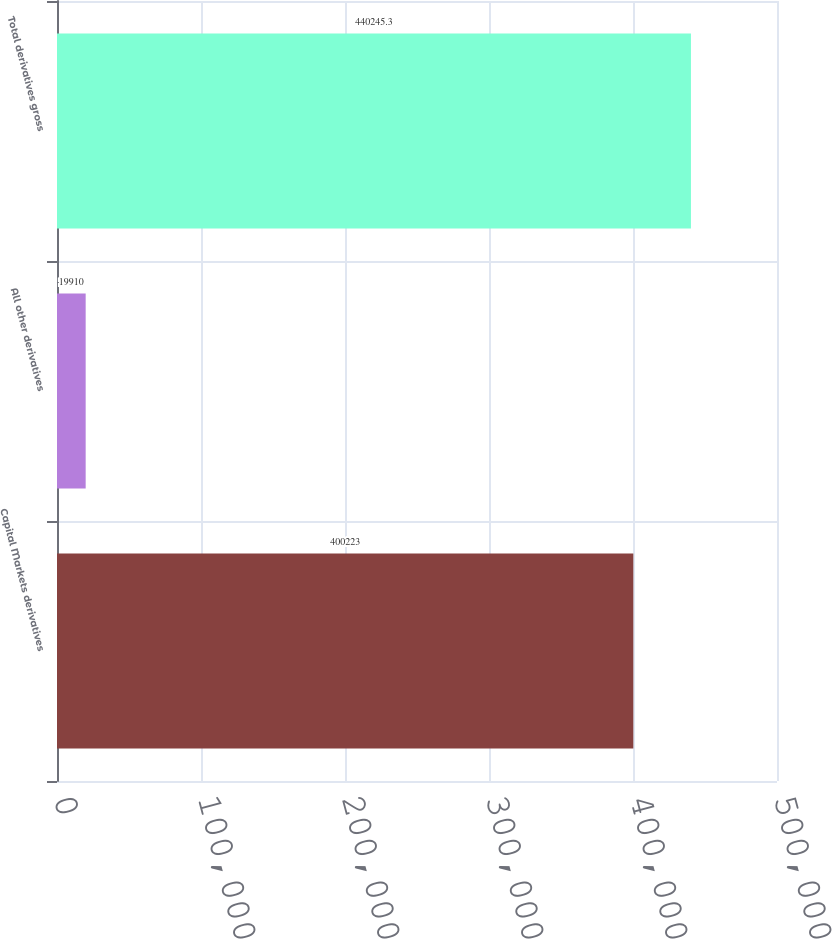<chart> <loc_0><loc_0><loc_500><loc_500><bar_chart><fcel>Capital Markets derivatives<fcel>All other derivatives<fcel>Total derivatives gross<nl><fcel>400223<fcel>19910<fcel>440245<nl></chart> 